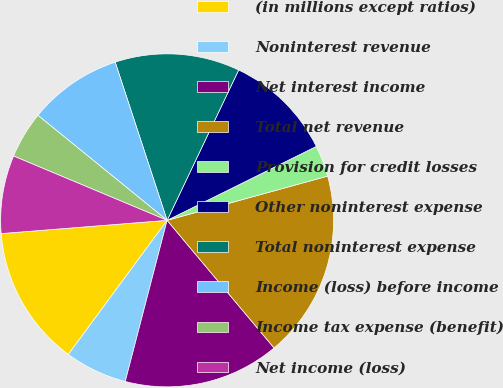<chart> <loc_0><loc_0><loc_500><loc_500><pie_chart><fcel>(in millions except ratios)<fcel>Noninterest revenue<fcel>Net interest income<fcel>Total net revenue<fcel>Provision for credit losses<fcel>Other noninterest expense<fcel>Total noninterest expense<fcel>Income (loss) before income<fcel>Income tax expense (benefit)<fcel>Net income (loss)<nl><fcel>13.63%<fcel>6.06%<fcel>15.15%<fcel>18.18%<fcel>3.04%<fcel>10.61%<fcel>12.12%<fcel>9.09%<fcel>4.55%<fcel>7.58%<nl></chart> 